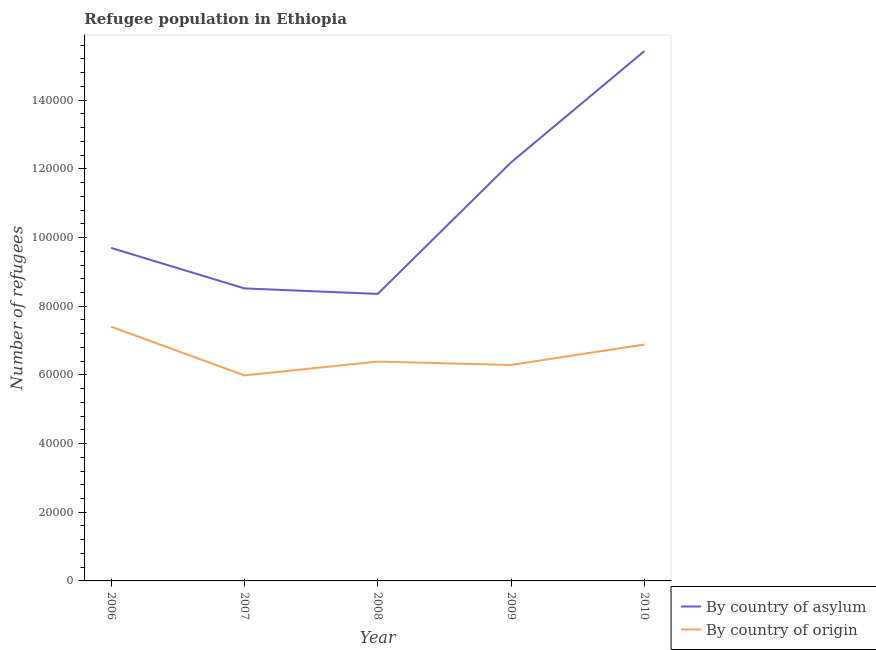Does the line corresponding to number of refugees by country of asylum intersect with the line corresponding to number of refugees by country of origin?
Your answer should be compact. No. What is the number of refugees by country of asylum in 2008?
Offer a terse response. 8.36e+04. Across all years, what is the maximum number of refugees by country of origin?
Ensure brevity in your answer.  7.40e+04. Across all years, what is the minimum number of refugees by country of origin?
Provide a succinct answer. 5.99e+04. In which year was the number of refugees by country of origin minimum?
Make the answer very short. 2007. What is the total number of refugees by country of origin in the graph?
Make the answer very short. 3.29e+05. What is the difference between the number of refugees by country of asylum in 2008 and that in 2009?
Provide a short and direct response. -3.83e+04. What is the difference between the number of refugees by country of asylum in 2008 and the number of refugees by country of origin in 2010?
Provide a succinct answer. 1.47e+04. What is the average number of refugees by country of origin per year?
Give a very brief answer. 6.59e+04. In the year 2006, what is the difference between the number of refugees by country of asylum and number of refugees by country of origin?
Provide a succinct answer. 2.30e+04. In how many years, is the number of refugees by country of origin greater than 24000?
Keep it short and to the point. 5. What is the ratio of the number of refugees by country of asylum in 2007 to that in 2009?
Make the answer very short. 0.7. Is the difference between the number of refugees by country of origin in 2007 and 2009 greater than the difference between the number of refugees by country of asylum in 2007 and 2009?
Make the answer very short. Yes. What is the difference between the highest and the second highest number of refugees by country of asylum?
Keep it short and to the point. 3.24e+04. What is the difference between the highest and the lowest number of refugees by country of asylum?
Provide a succinct answer. 7.07e+04. In how many years, is the number of refugees by country of origin greater than the average number of refugees by country of origin taken over all years?
Give a very brief answer. 2. Is the number of refugees by country of origin strictly greater than the number of refugees by country of asylum over the years?
Provide a short and direct response. No. Is the number of refugees by country of asylum strictly less than the number of refugees by country of origin over the years?
Give a very brief answer. No. How many lines are there?
Keep it short and to the point. 2. How many years are there in the graph?
Your response must be concise. 5. Does the graph contain grids?
Ensure brevity in your answer.  No. Where does the legend appear in the graph?
Make the answer very short. Bottom right. How many legend labels are there?
Ensure brevity in your answer.  2. What is the title of the graph?
Your answer should be compact. Refugee population in Ethiopia. What is the label or title of the X-axis?
Your answer should be compact. Year. What is the label or title of the Y-axis?
Ensure brevity in your answer.  Number of refugees. What is the Number of refugees of By country of asylum in 2006?
Offer a terse response. 9.70e+04. What is the Number of refugees in By country of origin in 2006?
Your response must be concise. 7.40e+04. What is the Number of refugees in By country of asylum in 2007?
Make the answer very short. 8.52e+04. What is the Number of refugees in By country of origin in 2007?
Give a very brief answer. 5.99e+04. What is the Number of refugees in By country of asylum in 2008?
Ensure brevity in your answer.  8.36e+04. What is the Number of refugees in By country of origin in 2008?
Provide a short and direct response. 6.39e+04. What is the Number of refugees in By country of asylum in 2009?
Your answer should be compact. 1.22e+05. What is the Number of refugees in By country of origin in 2009?
Your response must be concise. 6.29e+04. What is the Number of refugees in By country of asylum in 2010?
Offer a terse response. 1.54e+05. What is the Number of refugees of By country of origin in 2010?
Offer a very short reply. 6.88e+04. Across all years, what is the maximum Number of refugees of By country of asylum?
Provide a short and direct response. 1.54e+05. Across all years, what is the maximum Number of refugees in By country of origin?
Provide a succinct answer. 7.40e+04. Across all years, what is the minimum Number of refugees in By country of asylum?
Make the answer very short. 8.36e+04. Across all years, what is the minimum Number of refugees in By country of origin?
Ensure brevity in your answer.  5.99e+04. What is the total Number of refugees in By country of asylum in the graph?
Offer a terse response. 5.42e+05. What is the total Number of refugees of By country of origin in the graph?
Keep it short and to the point. 3.29e+05. What is the difference between the Number of refugees in By country of asylum in 2006 and that in 2007?
Offer a very short reply. 1.18e+04. What is the difference between the Number of refugees in By country of origin in 2006 and that in 2007?
Provide a succinct answer. 1.42e+04. What is the difference between the Number of refugees of By country of asylum in 2006 and that in 2008?
Keep it short and to the point. 1.34e+04. What is the difference between the Number of refugees of By country of origin in 2006 and that in 2008?
Give a very brief answer. 1.01e+04. What is the difference between the Number of refugees in By country of asylum in 2006 and that in 2009?
Your answer should be very brief. -2.49e+04. What is the difference between the Number of refugees of By country of origin in 2006 and that in 2009?
Your answer should be very brief. 1.11e+04. What is the difference between the Number of refugees in By country of asylum in 2006 and that in 2010?
Provide a succinct answer. -5.73e+04. What is the difference between the Number of refugees of By country of origin in 2006 and that in 2010?
Provide a short and direct response. 5178. What is the difference between the Number of refugees of By country of asylum in 2007 and that in 2008?
Your response must be concise. 1600. What is the difference between the Number of refugees in By country of origin in 2007 and that in 2008?
Give a very brief answer. -4020. What is the difference between the Number of refugees in By country of asylum in 2007 and that in 2009?
Your answer should be compact. -3.67e+04. What is the difference between the Number of refugees in By country of origin in 2007 and that in 2009?
Your answer should be compact. -3031. What is the difference between the Number of refugees of By country of asylum in 2007 and that in 2010?
Your answer should be compact. -6.91e+04. What is the difference between the Number of refugees in By country of origin in 2007 and that in 2010?
Ensure brevity in your answer.  -8990. What is the difference between the Number of refugees in By country of asylum in 2008 and that in 2009?
Provide a succinct answer. -3.83e+04. What is the difference between the Number of refugees in By country of origin in 2008 and that in 2009?
Your answer should be compact. 989. What is the difference between the Number of refugees of By country of asylum in 2008 and that in 2010?
Your response must be concise. -7.07e+04. What is the difference between the Number of refugees in By country of origin in 2008 and that in 2010?
Your answer should be compact. -4970. What is the difference between the Number of refugees in By country of asylum in 2009 and that in 2010?
Offer a terse response. -3.24e+04. What is the difference between the Number of refugees of By country of origin in 2009 and that in 2010?
Your answer should be compact. -5959. What is the difference between the Number of refugees of By country of asylum in 2006 and the Number of refugees of By country of origin in 2007?
Offer a very short reply. 3.71e+04. What is the difference between the Number of refugees in By country of asylum in 2006 and the Number of refugees in By country of origin in 2008?
Ensure brevity in your answer.  3.31e+04. What is the difference between the Number of refugees of By country of asylum in 2006 and the Number of refugees of By country of origin in 2009?
Ensure brevity in your answer.  3.41e+04. What is the difference between the Number of refugees in By country of asylum in 2006 and the Number of refugees in By country of origin in 2010?
Offer a very short reply. 2.81e+04. What is the difference between the Number of refugees in By country of asylum in 2007 and the Number of refugees in By country of origin in 2008?
Ensure brevity in your answer.  2.13e+04. What is the difference between the Number of refugees in By country of asylum in 2007 and the Number of refugees in By country of origin in 2009?
Make the answer very short. 2.23e+04. What is the difference between the Number of refugees of By country of asylum in 2007 and the Number of refugees of By country of origin in 2010?
Your answer should be very brief. 1.63e+04. What is the difference between the Number of refugees in By country of asylum in 2008 and the Number of refugees in By country of origin in 2009?
Give a very brief answer. 2.07e+04. What is the difference between the Number of refugees of By country of asylum in 2008 and the Number of refugees of By country of origin in 2010?
Offer a terse response. 1.47e+04. What is the difference between the Number of refugees of By country of asylum in 2009 and the Number of refugees of By country of origin in 2010?
Your answer should be very brief. 5.30e+04. What is the average Number of refugees of By country of asylum per year?
Provide a short and direct response. 1.08e+05. What is the average Number of refugees in By country of origin per year?
Offer a very short reply. 6.59e+04. In the year 2006, what is the difference between the Number of refugees in By country of asylum and Number of refugees in By country of origin?
Give a very brief answer. 2.30e+04. In the year 2007, what is the difference between the Number of refugees in By country of asylum and Number of refugees in By country of origin?
Your answer should be very brief. 2.53e+04. In the year 2008, what is the difference between the Number of refugees of By country of asylum and Number of refugees of By country of origin?
Offer a very short reply. 1.97e+04. In the year 2009, what is the difference between the Number of refugees in By country of asylum and Number of refugees in By country of origin?
Your answer should be compact. 5.90e+04. In the year 2010, what is the difference between the Number of refugees in By country of asylum and Number of refugees in By country of origin?
Keep it short and to the point. 8.54e+04. What is the ratio of the Number of refugees of By country of asylum in 2006 to that in 2007?
Offer a very short reply. 1.14. What is the ratio of the Number of refugees of By country of origin in 2006 to that in 2007?
Give a very brief answer. 1.24. What is the ratio of the Number of refugees of By country of asylum in 2006 to that in 2008?
Provide a short and direct response. 1.16. What is the ratio of the Number of refugees in By country of origin in 2006 to that in 2008?
Provide a short and direct response. 1.16. What is the ratio of the Number of refugees of By country of asylum in 2006 to that in 2009?
Provide a succinct answer. 0.8. What is the ratio of the Number of refugees of By country of origin in 2006 to that in 2009?
Provide a short and direct response. 1.18. What is the ratio of the Number of refugees in By country of asylum in 2006 to that in 2010?
Keep it short and to the point. 0.63. What is the ratio of the Number of refugees of By country of origin in 2006 to that in 2010?
Your answer should be very brief. 1.08. What is the ratio of the Number of refugees of By country of asylum in 2007 to that in 2008?
Your response must be concise. 1.02. What is the ratio of the Number of refugees in By country of origin in 2007 to that in 2008?
Ensure brevity in your answer.  0.94. What is the ratio of the Number of refugees of By country of asylum in 2007 to that in 2009?
Give a very brief answer. 0.7. What is the ratio of the Number of refugees in By country of origin in 2007 to that in 2009?
Ensure brevity in your answer.  0.95. What is the ratio of the Number of refugees of By country of asylum in 2007 to that in 2010?
Provide a short and direct response. 0.55. What is the ratio of the Number of refugees in By country of origin in 2007 to that in 2010?
Your response must be concise. 0.87. What is the ratio of the Number of refugees of By country of asylum in 2008 to that in 2009?
Your answer should be compact. 0.69. What is the ratio of the Number of refugees of By country of origin in 2008 to that in 2009?
Your answer should be compact. 1.02. What is the ratio of the Number of refugees in By country of asylum in 2008 to that in 2010?
Offer a terse response. 0.54. What is the ratio of the Number of refugees in By country of origin in 2008 to that in 2010?
Offer a terse response. 0.93. What is the ratio of the Number of refugees in By country of asylum in 2009 to that in 2010?
Your answer should be compact. 0.79. What is the ratio of the Number of refugees in By country of origin in 2009 to that in 2010?
Provide a short and direct response. 0.91. What is the difference between the highest and the second highest Number of refugees in By country of asylum?
Your answer should be compact. 3.24e+04. What is the difference between the highest and the second highest Number of refugees of By country of origin?
Ensure brevity in your answer.  5178. What is the difference between the highest and the lowest Number of refugees of By country of asylum?
Give a very brief answer. 7.07e+04. What is the difference between the highest and the lowest Number of refugees of By country of origin?
Ensure brevity in your answer.  1.42e+04. 